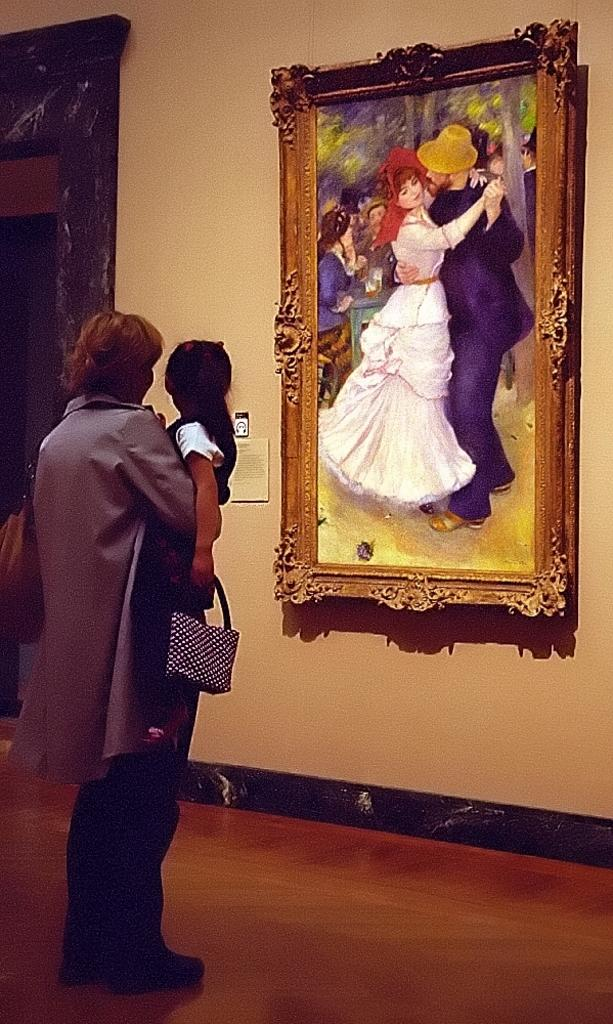How many people are in the image? There are two people in the image. What can be seen on the wall in the image? There is a painting on the wall. Can you describe the object in the top left hand corner of the image? Unfortunately, the facts provided do not give any information about the object in the top left hand corner. What is visible under the people's feet in the image? The floor is visible in the image. What type of ship can be seen sailing in the background of the image? There is no ship visible in the image; it only contains two people, a painting on the wall, and an unidentified object in the top left hand corner. 